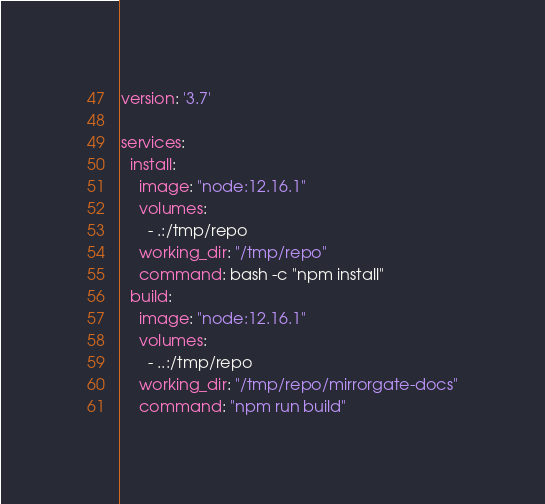<code> <loc_0><loc_0><loc_500><loc_500><_YAML_>version: '3.7'

services:
  install:
    image: "node:12.16.1"
    volumes:
      - .:/tmp/repo
    working_dir: "/tmp/repo"
    command: bash -c "npm install"
  build:
    image: "node:12.16.1"
    volumes:
      - ..:/tmp/repo
    working_dir: "/tmp/repo/mirrorgate-docs"
    command: "npm run build"
</code> 